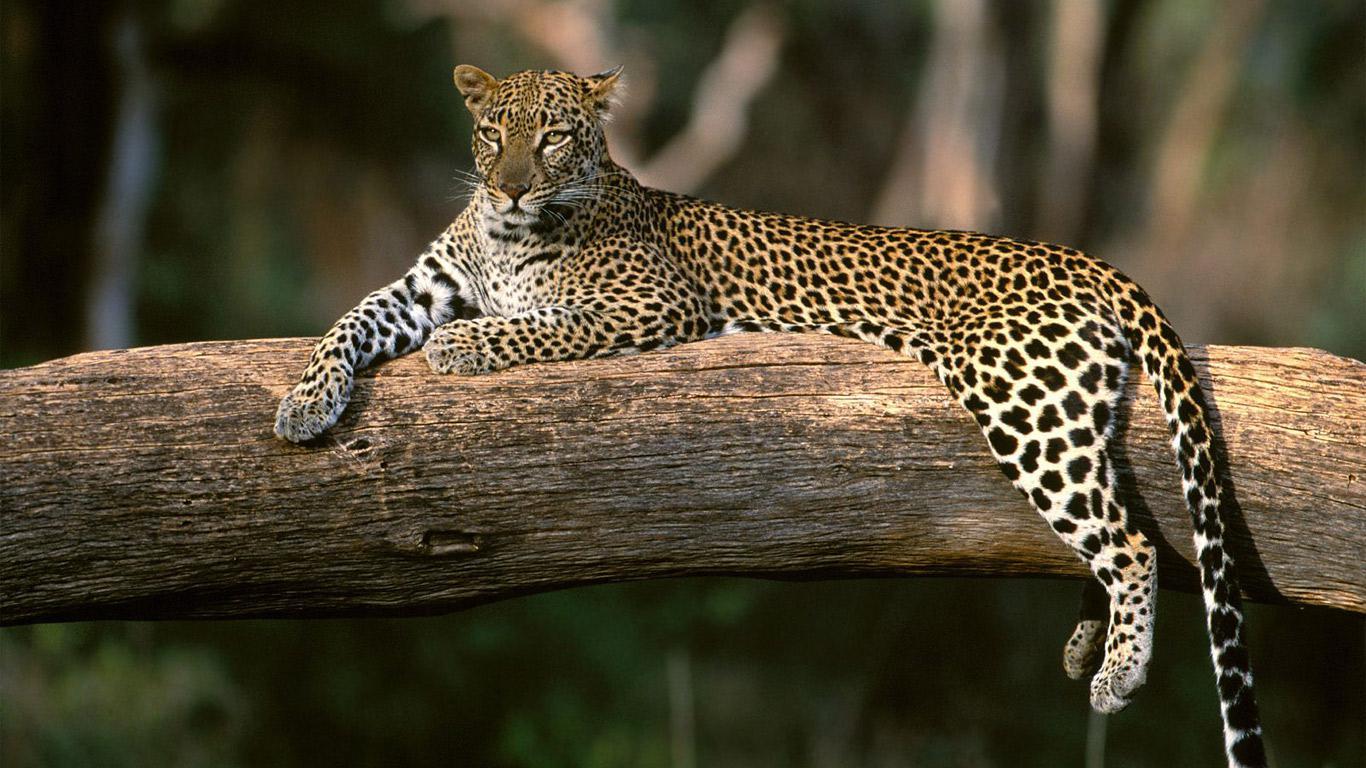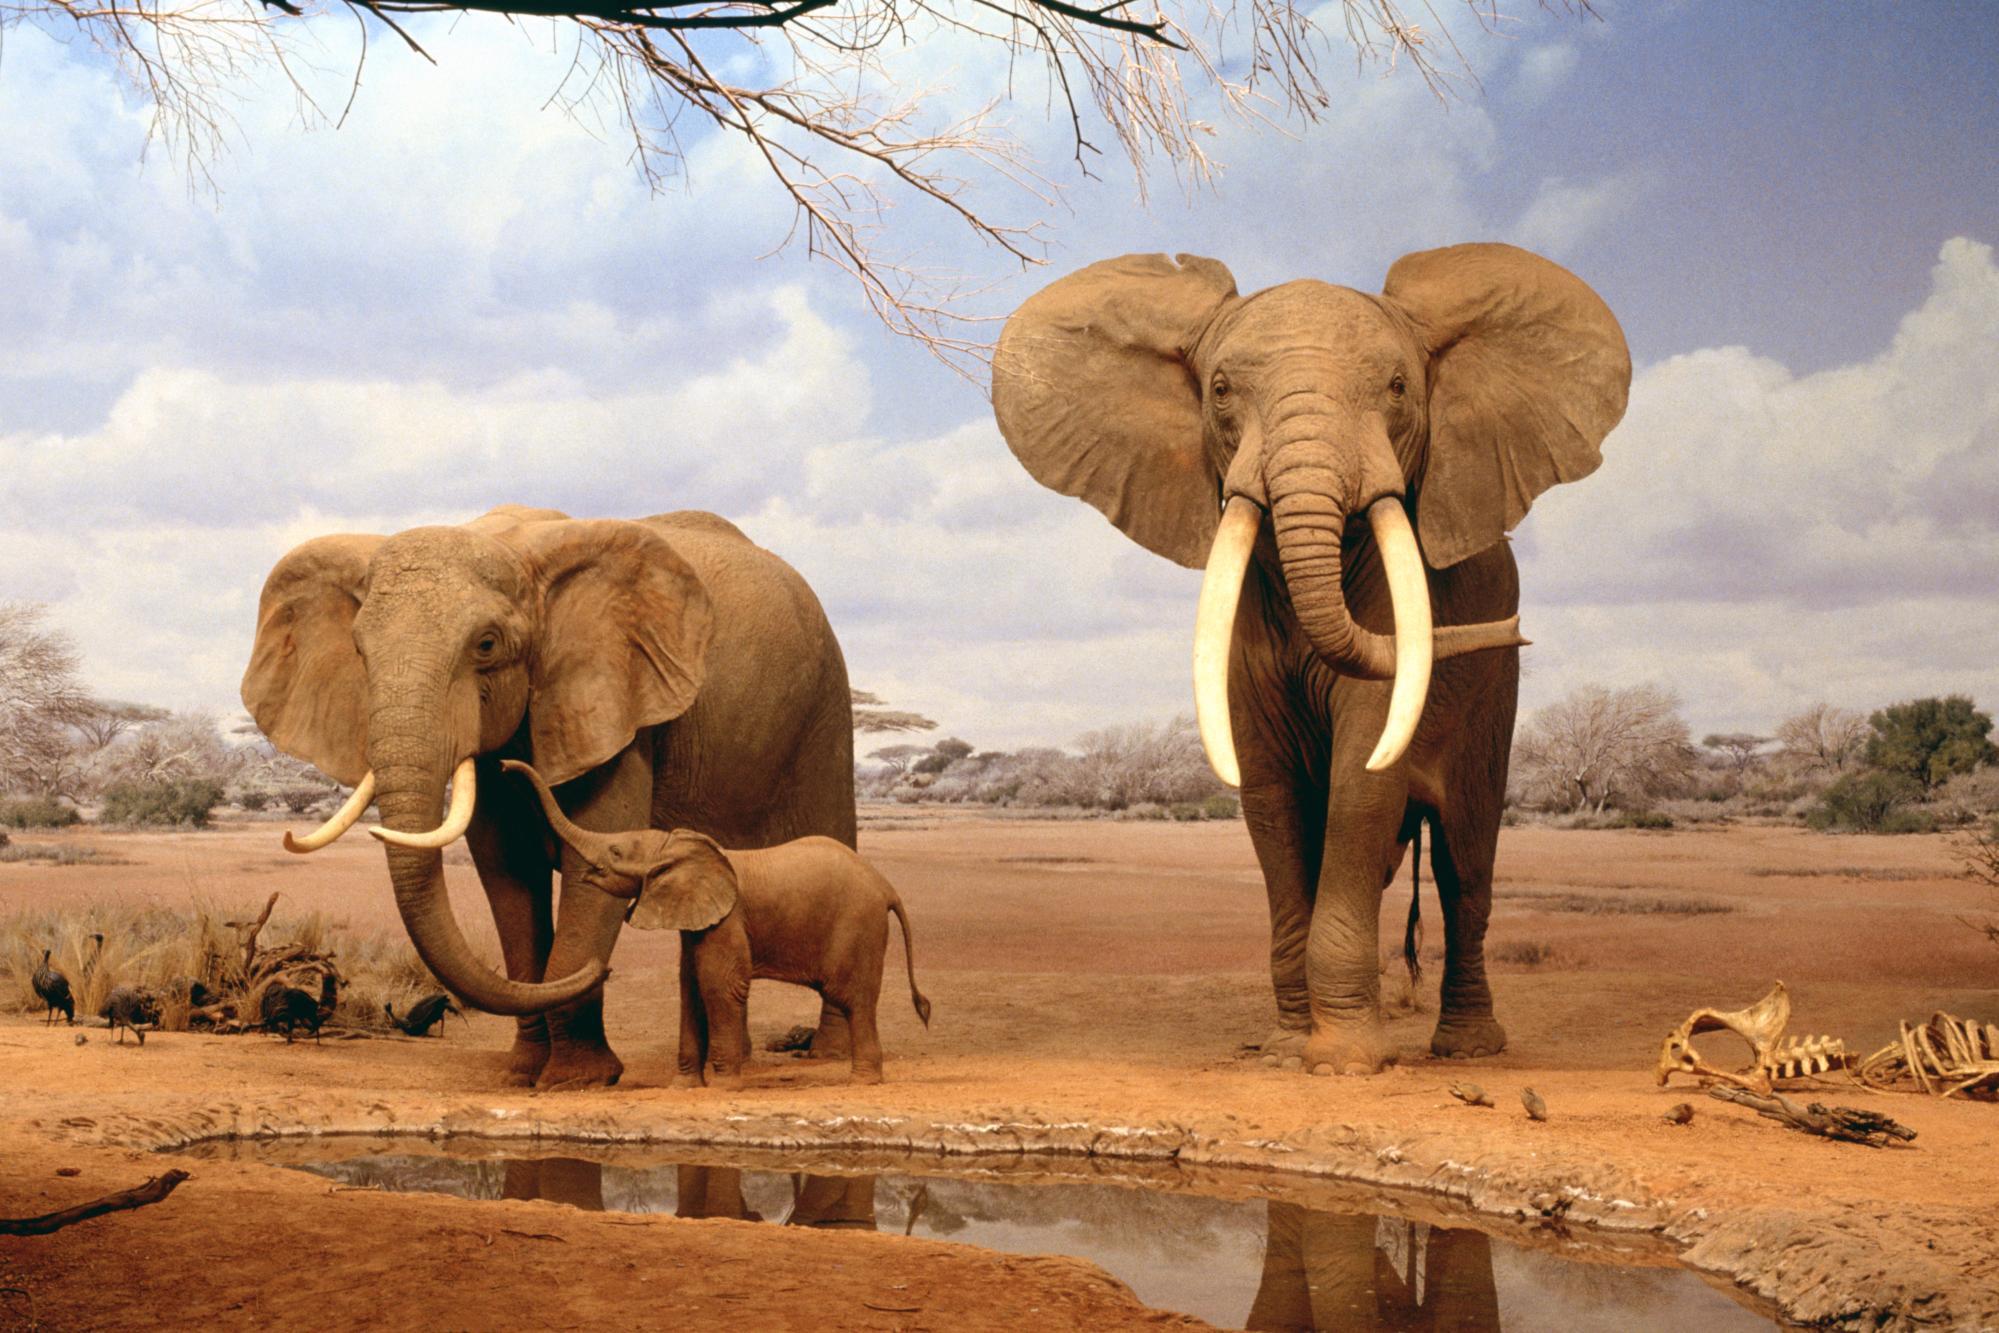The first image is the image on the left, the second image is the image on the right. For the images shown, is this caption "Each picture shows exactly two zebras." true? Answer yes or no. No. 